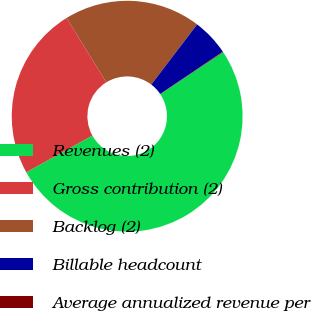Convert chart. <chart><loc_0><loc_0><loc_500><loc_500><pie_chart><fcel>Revenues (2)<fcel>Gross contribution (2)<fcel>Backlog (2)<fcel>Billable headcount<fcel>Average annualized revenue per<nl><fcel>51.3%<fcel>24.28%<fcel>19.16%<fcel>5.19%<fcel>0.07%<nl></chart> 